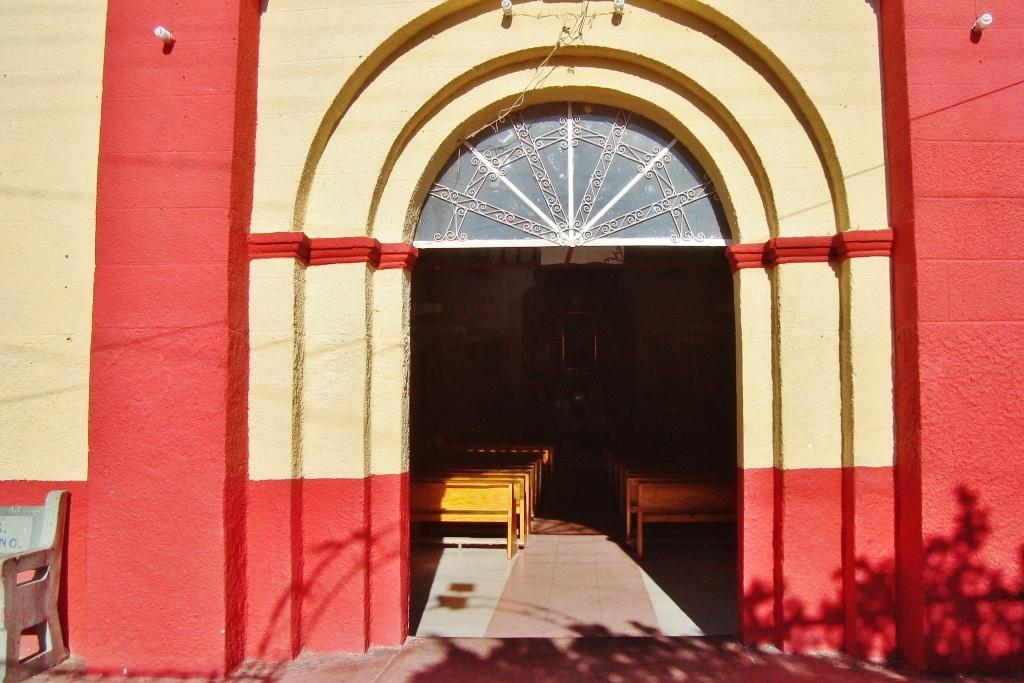What is the main structure visible in the image? There is a building wall in the image. What type of furniture is present on the floor in the image? There are benches on the floor in the image. Can you describe the location of the bench outside the building? There is a bench kept outside of the building in the image. What type of seed is being planted by the hands in the image? There are no hands or seeds present in the image. How many chickens can be seen roaming around the benches in the image? There are no chickens present in the image. 